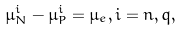Convert formula to latex. <formula><loc_0><loc_0><loc_500><loc_500>\mu _ { N } ^ { i } - \mu _ { P } ^ { i } = \mu _ { e } , i = n , q ,</formula> 